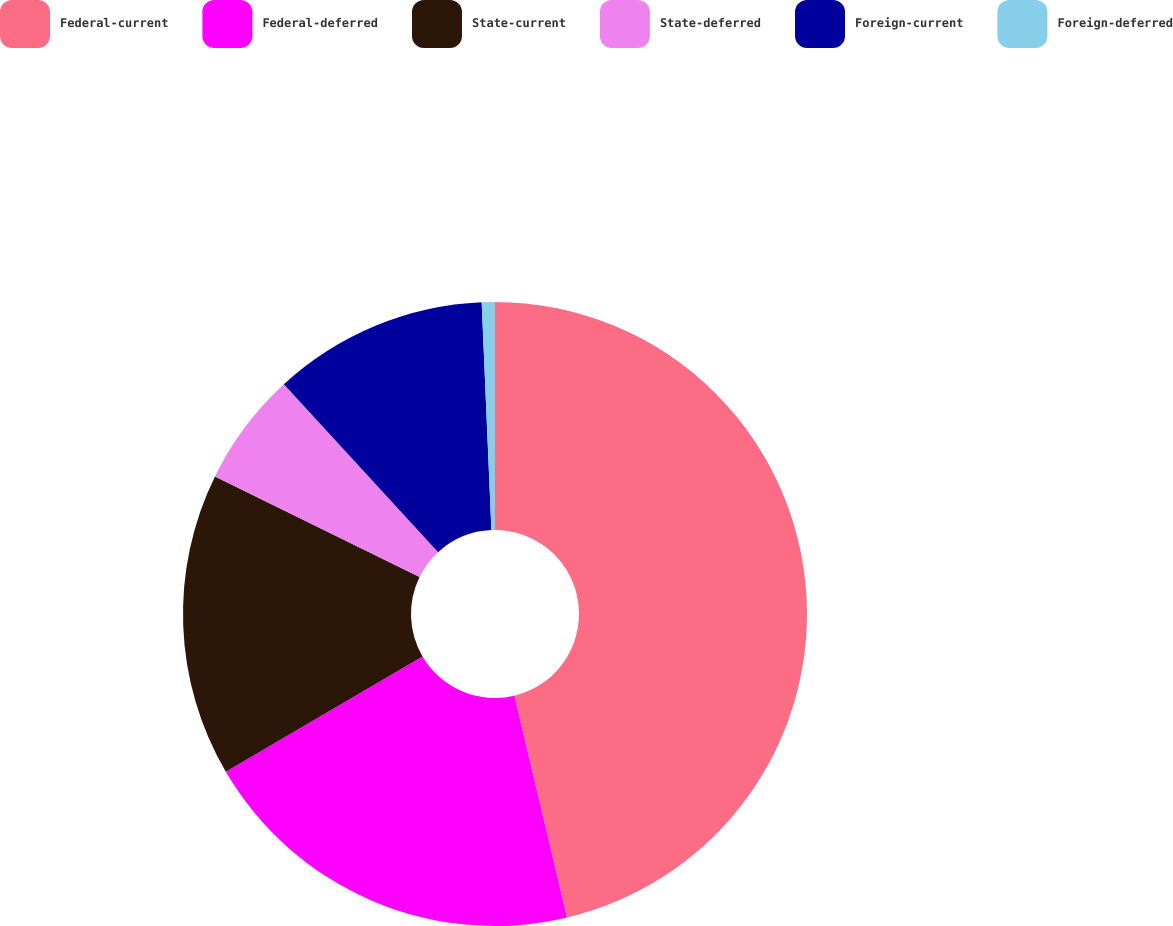Convert chart. <chart><loc_0><loc_0><loc_500><loc_500><pie_chart><fcel>Federal-current<fcel>Federal-deferred<fcel>State-current<fcel>State-deferred<fcel>Foreign-current<fcel>Foreign-deferred<nl><fcel>46.29%<fcel>20.27%<fcel>15.71%<fcel>5.9%<fcel>11.15%<fcel>0.68%<nl></chart> 